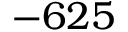Convert formula to latex. <formula><loc_0><loc_0><loc_500><loc_500>- 6 2 5</formula> 